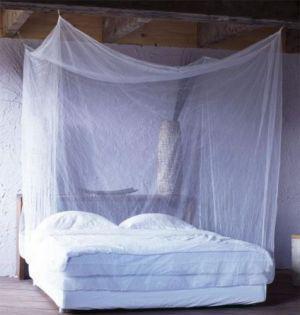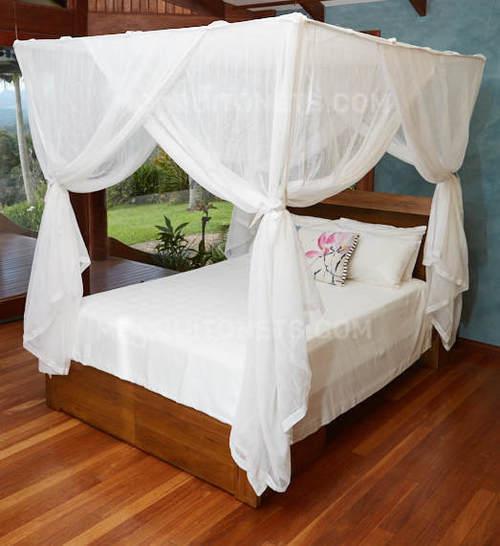The first image is the image on the left, the second image is the image on the right. For the images displayed, is the sentence "The left image shows a dome canopy with an open side." factually correct? Answer yes or no. No. 